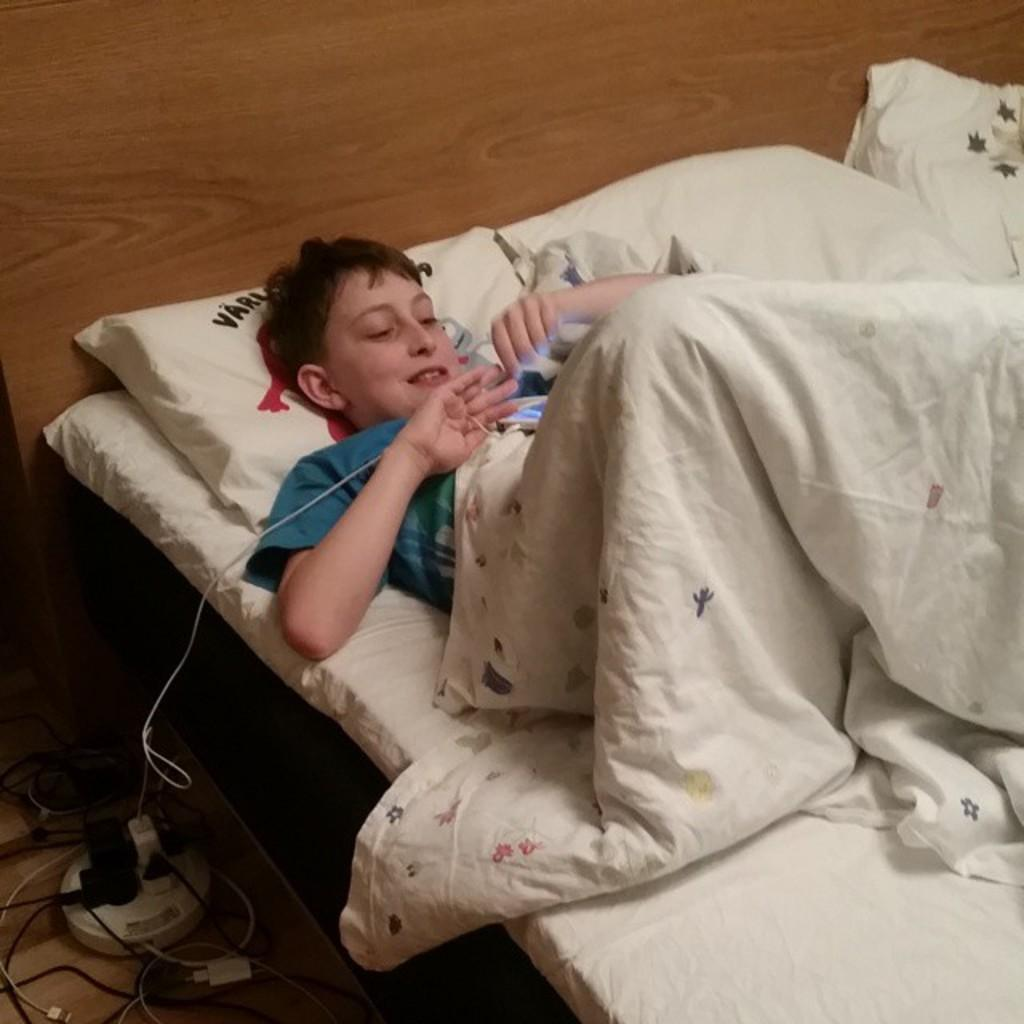What is the person in the image doing? The person is sitting on the bed. What is the person wearing while sitting on the bed? The person is wearing a blanket. What is the facial expression of the person in the image? The person is smiling. What can be seen on the bed besides the person? There are pillows on the bed. What is present on the floor in the image? There are cable cards on the floor. What type of match is being used by the person in the image? There is no match present in the image; the person is wearing a blanket and sitting on the bed. 